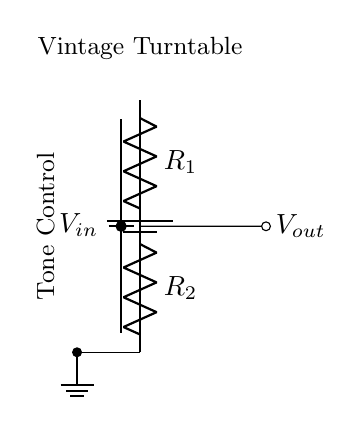What is the input voltage labeled in the circuit? The input voltage is labeled as V_in in the circuit diagram. It represents the voltage supplied to the circuit.
Answer: V_in What are the two resistor values in the circuit? The circuit contains two resistors labeled as R_1 and R_2. They are represented in the diagram but their specific values are not provided, just their identifiers.
Answer: R_1 and R_2 What is the output voltage in terms of the input voltage and resistor values? The output voltage V_out in a voltage divider circuit is given by the formula V_out = V_in * (R_2 / (R_1 + R_2)). This relationship shows how V_out depends on the resistor values and input voltage.
Answer: V_out = V_in * (R_2 / (R_1 + R_2)) What is the primary function of this circuit? The primary function of a voltage divider circuit is to divide the input voltage into a lower output voltage, which is useful for tone control in audio applications like vintage turntables.
Answer: Tone Control How many components are connected in series in this circuit? There are three components directly connected in series in the circuit: V_in, R_1, and R_2. The series connection means there is only one path for the current to flow.
Answer: Three What component is missing that would allow for adjustable output? The diagram indicates that the circuit lacks a potentiometer, which allows for adjustable resistance and thus adjustable output voltage, crucial for precise tone control adjustments in the turntable.
Answer: Potentiometer What does the ground symbol indicate in the circuit? The ground symbol represents the common reference point for the circuit, where the voltage is considered to be zero. It completes the circuit allowing current to flow, which is essential for proper operation.
Answer: Ground 